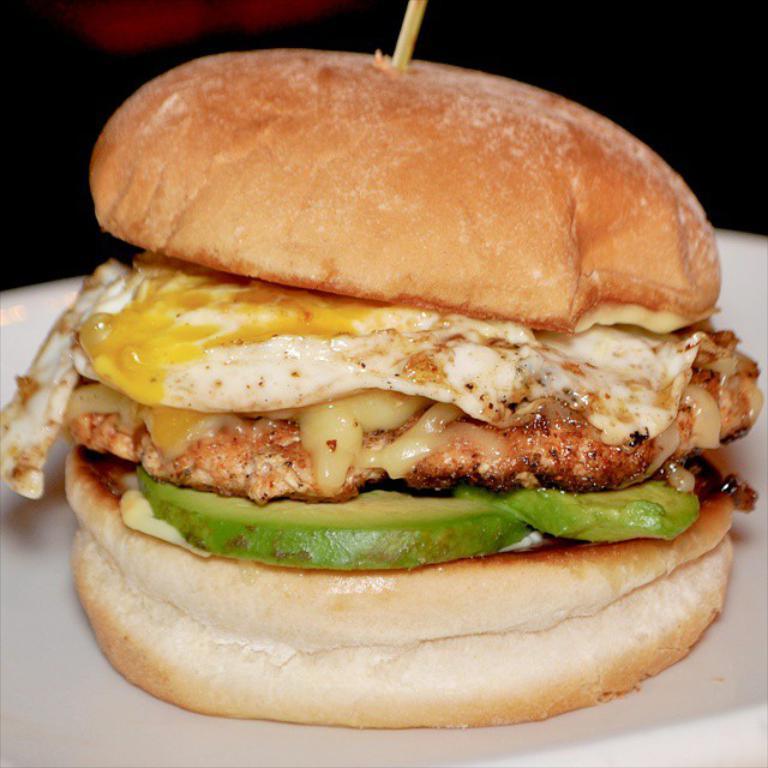Could you give a brief overview of what you see in this image? In this image we can see a burger with a stick placed on the plate. 